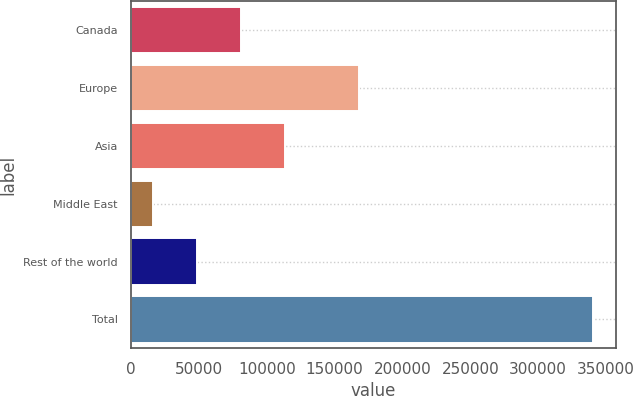Convert chart. <chart><loc_0><loc_0><loc_500><loc_500><bar_chart><fcel>Canada<fcel>Europe<fcel>Asia<fcel>Middle East<fcel>Rest of the world<fcel>Total<nl><fcel>80793.8<fcel>167698<fcel>113252<fcel>15877<fcel>48335.4<fcel>340461<nl></chart> 